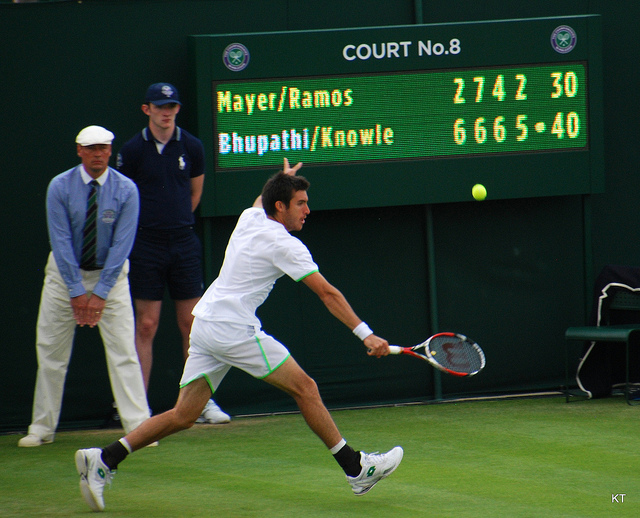Please extract the text content from this image. COURT Mayer Ramos 2742 30 /Knowle Bhupathi KT 40 6665 .8 No. 